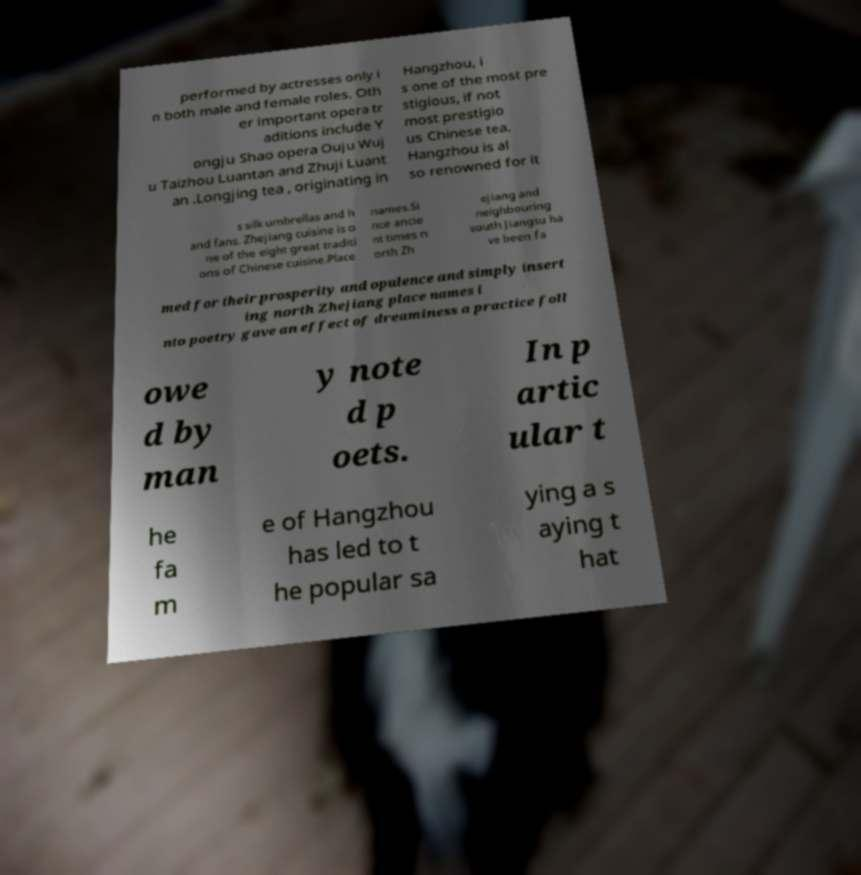Could you assist in decoding the text presented in this image and type it out clearly? performed by actresses only i n both male and female roles. Oth er important opera tr aditions include Y ongju Shao opera Ouju Wuj u Taizhou Luantan and Zhuji Luant an .Longjing tea , originating in Hangzhou, i s one of the most pre stigious, if not most prestigio us Chinese tea. Hangzhou is al so renowned for it s silk umbrellas and h and fans. Zhejiang cuisine is o ne of the eight great traditi ons of Chinese cuisine.Place names.Si nce ancie nt times n orth Zh ejiang and neighbouring south Jiangsu ha ve been fa med for their prosperity and opulence and simply insert ing north Zhejiang place names i nto poetry gave an effect of dreaminess a practice foll owe d by man y note d p oets. In p artic ular t he fa m e of Hangzhou has led to t he popular sa ying a s aying t hat 